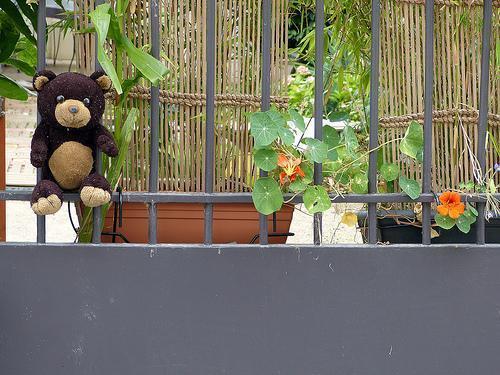How many toys are there?
Give a very brief answer. 1. 